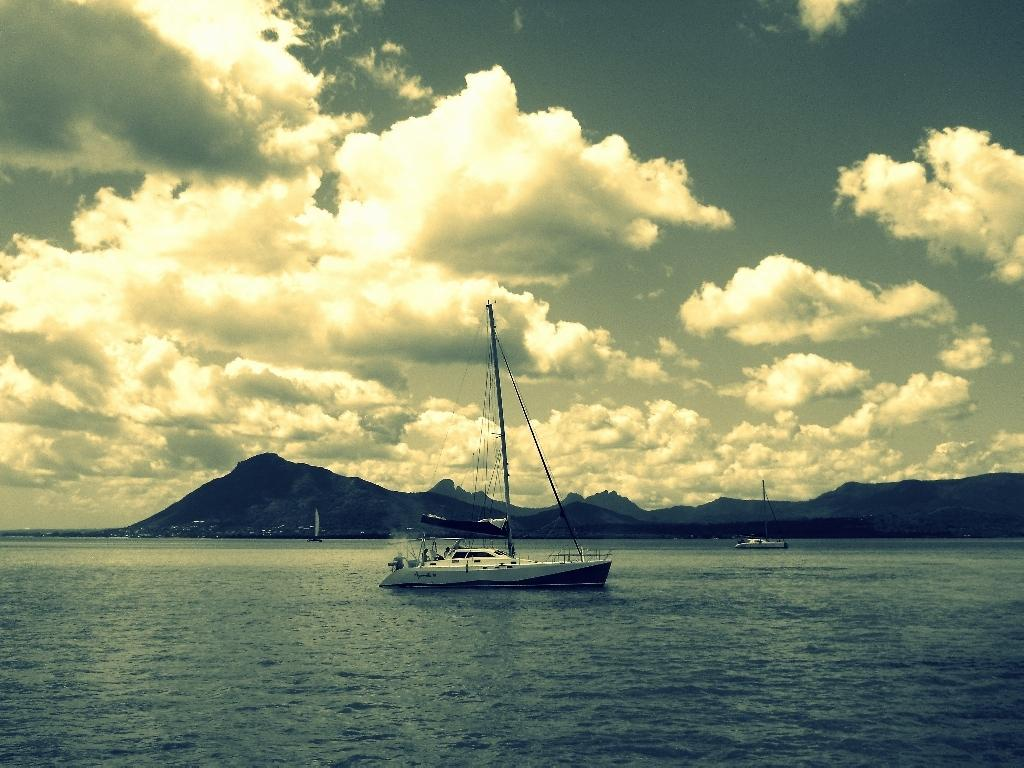What is on the surface of the water in the image? There are boats on the surface of the water in the image. What can be seen in the background of the image? There are hills visible in the background of the image. What is visible above the water and hills in the image? The sky is visible in the image. What can be observed in the sky in the image? Clouds are present in the sky. Can you see a kite flying in the image? There is no kite present in the image. What type of transport is being used by the boats in the image? The boats in the image are on the water's surface, so there is no need for additional transport. 